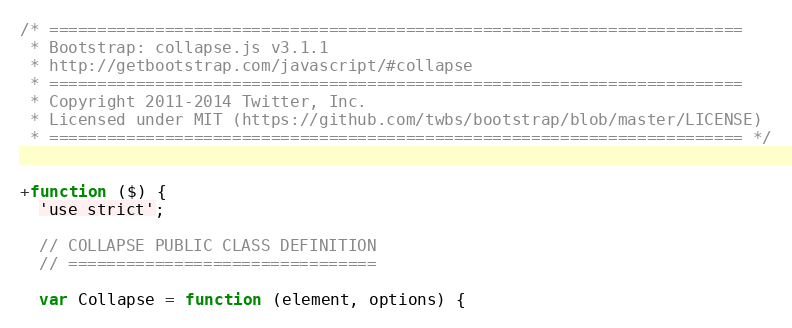<code> <loc_0><loc_0><loc_500><loc_500><_JavaScript_>/* ========================================================================
 * Bootstrap: collapse.js v3.1.1
 * http://getbootstrap.com/javascript/#collapse
 * ========================================================================
 * Copyright 2011-2014 Twitter, Inc.
 * Licensed under MIT (https://github.com/twbs/bootstrap/blob/master/LICENSE)
 * ======================================================================== */


+function ($) {
  'use strict';

  // COLLAPSE PUBLIC CLASS DEFINITION
  // ================================

  var Collapse = function (element, options) {</code> 